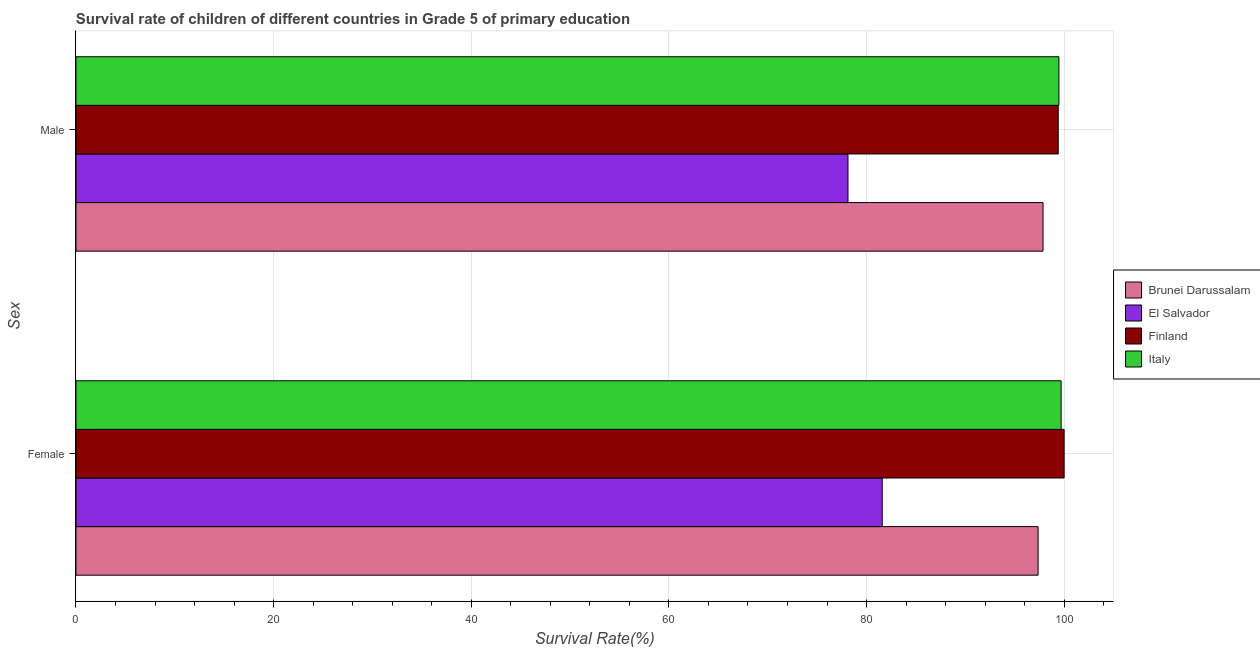Are the number of bars on each tick of the Y-axis equal?
Provide a short and direct response. Yes. How many bars are there on the 1st tick from the top?
Ensure brevity in your answer.  4. What is the label of the 2nd group of bars from the top?
Your answer should be very brief. Female. What is the survival rate of male students in primary education in Finland?
Keep it short and to the point. 99.4. Across all countries, what is the maximum survival rate of male students in primary education?
Make the answer very short. 99.47. Across all countries, what is the minimum survival rate of male students in primary education?
Your answer should be very brief. 78.12. In which country was the survival rate of male students in primary education minimum?
Provide a short and direct response. El Salvador. What is the total survival rate of male students in primary education in the graph?
Provide a succinct answer. 374.85. What is the difference between the survival rate of female students in primary education in Finland and that in Italy?
Provide a succinct answer. 0.3. What is the difference between the survival rate of male students in primary education in Brunei Darussalam and the survival rate of female students in primary education in El Salvador?
Provide a succinct answer. 16.27. What is the average survival rate of male students in primary education per country?
Keep it short and to the point. 93.71. What is the difference between the survival rate of female students in primary education and survival rate of male students in primary education in Brunei Darussalam?
Your response must be concise. -0.5. In how many countries, is the survival rate of female students in primary education greater than 88 %?
Keep it short and to the point. 3. What is the ratio of the survival rate of male students in primary education in Brunei Darussalam to that in Finland?
Your response must be concise. 0.98. Is the survival rate of male students in primary education in El Salvador less than that in Finland?
Keep it short and to the point. Yes. In how many countries, is the survival rate of male students in primary education greater than the average survival rate of male students in primary education taken over all countries?
Provide a succinct answer. 3. What does the 2nd bar from the bottom in Female represents?
Offer a terse response. El Salvador. Are all the bars in the graph horizontal?
Offer a very short reply. Yes. What is the difference between two consecutive major ticks on the X-axis?
Offer a very short reply. 20. Are the values on the major ticks of X-axis written in scientific E-notation?
Your response must be concise. No. Does the graph contain grids?
Your response must be concise. Yes. How many legend labels are there?
Provide a short and direct response. 4. How are the legend labels stacked?
Make the answer very short. Vertical. What is the title of the graph?
Your response must be concise. Survival rate of children of different countries in Grade 5 of primary education. Does "Sub-Saharan Africa (developing only)" appear as one of the legend labels in the graph?
Your response must be concise. No. What is the label or title of the X-axis?
Your answer should be very brief. Survival Rate(%). What is the label or title of the Y-axis?
Make the answer very short. Sex. What is the Survival Rate(%) in Brunei Darussalam in Female?
Offer a terse response. 97.36. What is the Survival Rate(%) in El Salvador in Female?
Your response must be concise. 81.59. What is the Survival Rate(%) in Finland in Female?
Offer a very short reply. 100. What is the Survival Rate(%) of Italy in Female?
Ensure brevity in your answer.  99.69. What is the Survival Rate(%) of Brunei Darussalam in Male?
Offer a very short reply. 97.86. What is the Survival Rate(%) of El Salvador in Male?
Give a very brief answer. 78.12. What is the Survival Rate(%) in Finland in Male?
Provide a short and direct response. 99.4. What is the Survival Rate(%) of Italy in Male?
Make the answer very short. 99.47. Across all Sex, what is the maximum Survival Rate(%) in Brunei Darussalam?
Your answer should be very brief. 97.86. Across all Sex, what is the maximum Survival Rate(%) of El Salvador?
Keep it short and to the point. 81.59. Across all Sex, what is the maximum Survival Rate(%) in Finland?
Give a very brief answer. 100. Across all Sex, what is the maximum Survival Rate(%) in Italy?
Offer a very short reply. 99.69. Across all Sex, what is the minimum Survival Rate(%) of Brunei Darussalam?
Keep it short and to the point. 97.36. Across all Sex, what is the minimum Survival Rate(%) of El Salvador?
Offer a very short reply. 78.12. Across all Sex, what is the minimum Survival Rate(%) of Finland?
Make the answer very short. 99.4. Across all Sex, what is the minimum Survival Rate(%) of Italy?
Your response must be concise. 99.47. What is the total Survival Rate(%) of Brunei Darussalam in the graph?
Ensure brevity in your answer.  195.22. What is the total Survival Rate(%) of El Salvador in the graph?
Your answer should be very brief. 159.71. What is the total Survival Rate(%) in Finland in the graph?
Keep it short and to the point. 199.4. What is the total Survival Rate(%) of Italy in the graph?
Keep it short and to the point. 199.16. What is the difference between the Survival Rate(%) of Brunei Darussalam in Female and that in Male?
Your answer should be compact. -0.5. What is the difference between the Survival Rate(%) of El Salvador in Female and that in Male?
Provide a succinct answer. 3.46. What is the difference between the Survival Rate(%) in Finland in Female and that in Male?
Give a very brief answer. 0.6. What is the difference between the Survival Rate(%) of Italy in Female and that in Male?
Ensure brevity in your answer.  0.23. What is the difference between the Survival Rate(%) in Brunei Darussalam in Female and the Survival Rate(%) in El Salvador in Male?
Provide a short and direct response. 19.24. What is the difference between the Survival Rate(%) of Brunei Darussalam in Female and the Survival Rate(%) of Finland in Male?
Your answer should be very brief. -2.04. What is the difference between the Survival Rate(%) of Brunei Darussalam in Female and the Survival Rate(%) of Italy in Male?
Keep it short and to the point. -2.11. What is the difference between the Survival Rate(%) of El Salvador in Female and the Survival Rate(%) of Finland in Male?
Keep it short and to the point. -17.81. What is the difference between the Survival Rate(%) of El Salvador in Female and the Survival Rate(%) of Italy in Male?
Offer a very short reply. -17.88. What is the difference between the Survival Rate(%) of Finland in Female and the Survival Rate(%) of Italy in Male?
Offer a very short reply. 0.53. What is the average Survival Rate(%) in Brunei Darussalam per Sex?
Make the answer very short. 97.61. What is the average Survival Rate(%) of El Salvador per Sex?
Ensure brevity in your answer.  79.86. What is the average Survival Rate(%) of Finland per Sex?
Give a very brief answer. 99.7. What is the average Survival Rate(%) of Italy per Sex?
Your response must be concise. 99.58. What is the difference between the Survival Rate(%) of Brunei Darussalam and Survival Rate(%) of El Salvador in Female?
Offer a very short reply. 15.77. What is the difference between the Survival Rate(%) in Brunei Darussalam and Survival Rate(%) in Finland in Female?
Offer a very short reply. -2.64. What is the difference between the Survival Rate(%) in Brunei Darussalam and Survival Rate(%) in Italy in Female?
Ensure brevity in your answer.  -2.33. What is the difference between the Survival Rate(%) of El Salvador and Survival Rate(%) of Finland in Female?
Keep it short and to the point. -18.41. What is the difference between the Survival Rate(%) in El Salvador and Survival Rate(%) in Italy in Female?
Give a very brief answer. -18.1. What is the difference between the Survival Rate(%) in Finland and Survival Rate(%) in Italy in Female?
Offer a terse response. 0.3. What is the difference between the Survival Rate(%) in Brunei Darussalam and Survival Rate(%) in El Salvador in Male?
Provide a succinct answer. 19.74. What is the difference between the Survival Rate(%) in Brunei Darussalam and Survival Rate(%) in Finland in Male?
Provide a short and direct response. -1.54. What is the difference between the Survival Rate(%) of Brunei Darussalam and Survival Rate(%) of Italy in Male?
Provide a short and direct response. -1.61. What is the difference between the Survival Rate(%) of El Salvador and Survival Rate(%) of Finland in Male?
Your answer should be compact. -21.28. What is the difference between the Survival Rate(%) in El Salvador and Survival Rate(%) in Italy in Male?
Offer a very short reply. -21.34. What is the difference between the Survival Rate(%) of Finland and Survival Rate(%) of Italy in Male?
Provide a succinct answer. -0.07. What is the ratio of the Survival Rate(%) in El Salvador in Female to that in Male?
Your response must be concise. 1.04. What is the difference between the highest and the second highest Survival Rate(%) in Brunei Darussalam?
Your answer should be very brief. 0.5. What is the difference between the highest and the second highest Survival Rate(%) of El Salvador?
Offer a very short reply. 3.46. What is the difference between the highest and the second highest Survival Rate(%) of Finland?
Offer a terse response. 0.6. What is the difference between the highest and the second highest Survival Rate(%) of Italy?
Your response must be concise. 0.23. What is the difference between the highest and the lowest Survival Rate(%) of Brunei Darussalam?
Keep it short and to the point. 0.5. What is the difference between the highest and the lowest Survival Rate(%) of El Salvador?
Provide a succinct answer. 3.46. What is the difference between the highest and the lowest Survival Rate(%) of Finland?
Your answer should be compact. 0.6. What is the difference between the highest and the lowest Survival Rate(%) in Italy?
Offer a terse response. 0.23. 